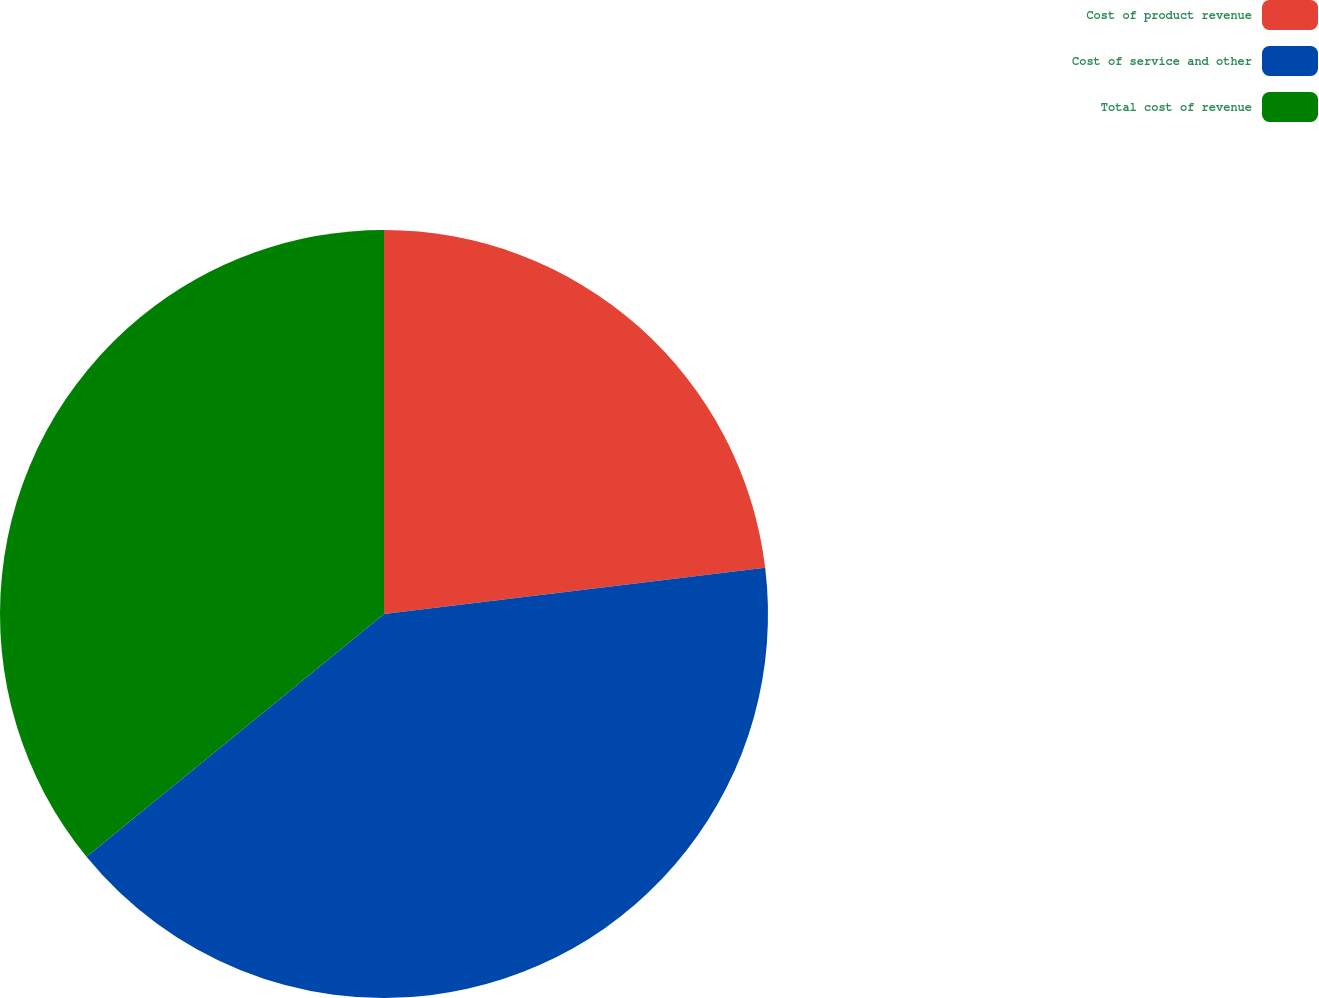<chart> <loc_0><loc_0><loc_500><loc_500><pie_chart><fcel>Cost of product revenue<fcel>Cost of service and other<fcel>Total cost of revenue<nl><fcel>23.08%<fcel>41.03%<fcel>35.9%<nl></chart> 